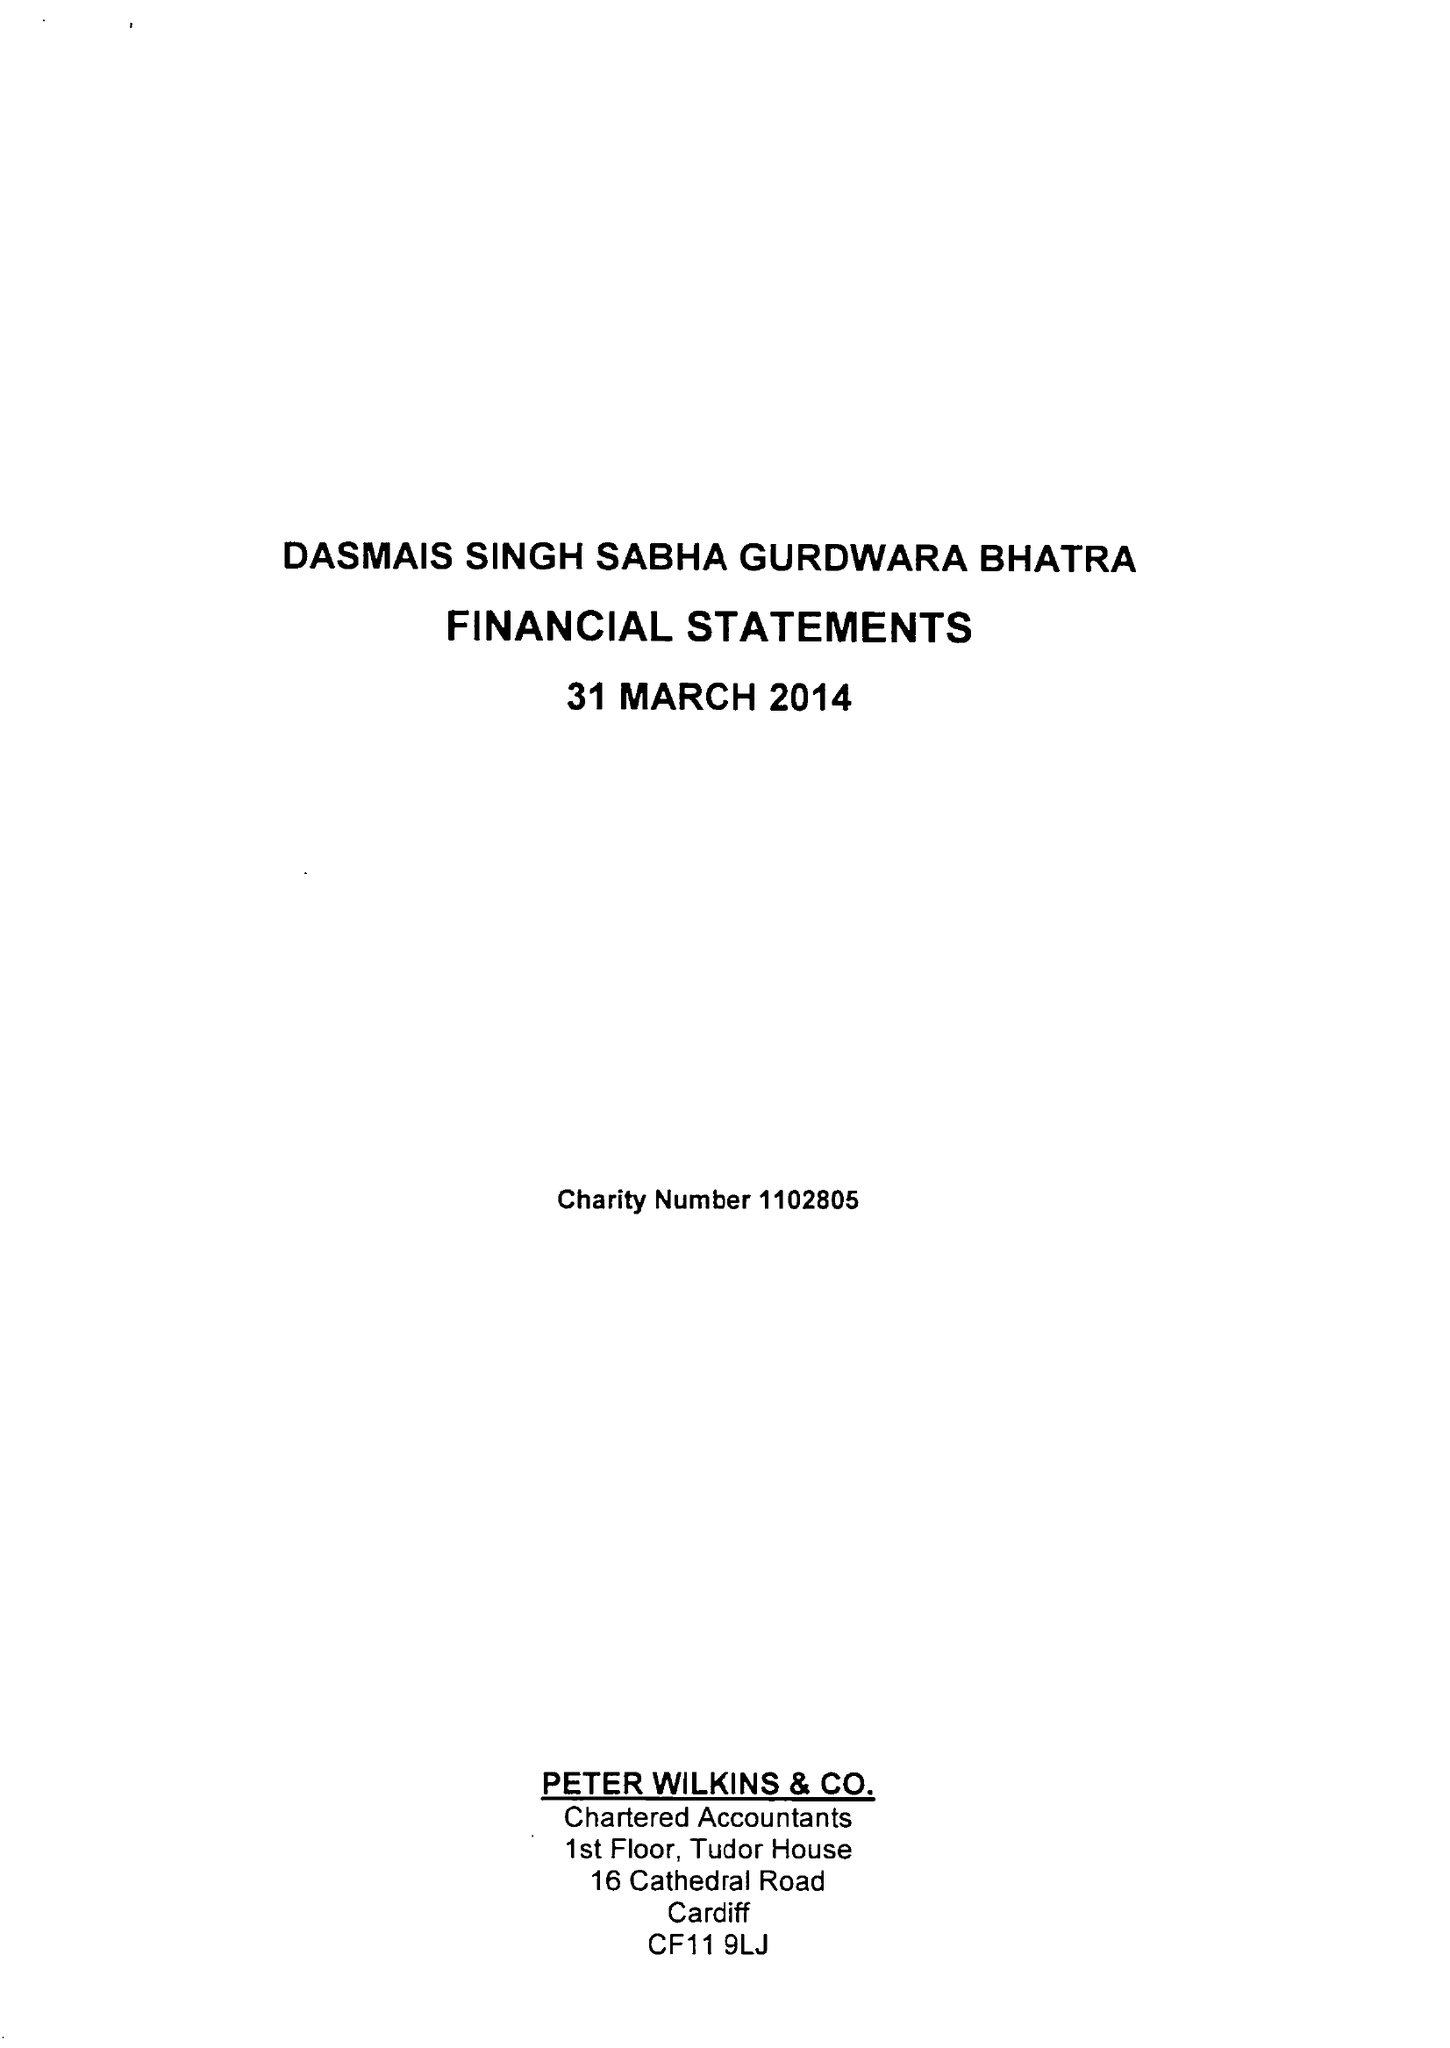What is the value for the address__post_town?
Answer the question using a single word or phrase. CARDIFF 